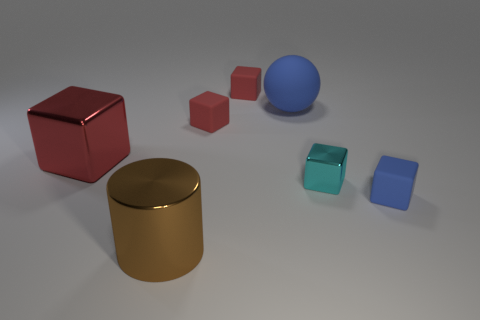Subtract all red blocks. How many were subtracted if there are1red blocks left? 2 Subtract all brown balls. How many red blocks are left? 3 Subtract all blue cubes. How many cubes are left? 4 Subtract all big red metallic cubes. How many cubes are left? 4 Add 2 metal blocks. How many objects exist? 9 Subtract all purple cubes. Subtract all purple cylinders. How many cubes are left? 5 Subtract all cubes. How many objects are left? 2 Add 6 metallic objects. How many metallic objects exist? 9 Subtract 0 cyan spheres. How many objects are left? 7 Subtract all cyan metal cubes. Subtract all small cyan metal blocks. How many objects are left? 5 